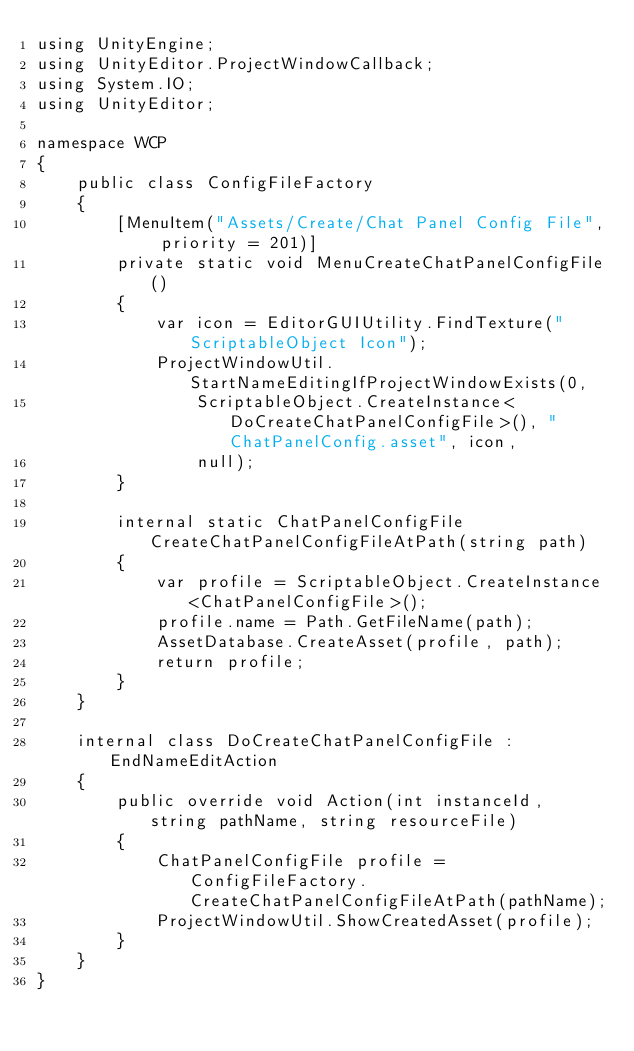<code> <loc_0><loc_0><loc_500><loc_500><_C#_>using UnityEngine;
using UnityEditor.ProjectWindowCallback;
using System.IO;
using UnityEditor;

namespace WCP
{
    public class ConfigFileFactory
    {
        [MenuItem("Assets/Create/Chat Panel Config File", priority = 201)]
        private static void MenuCreateChatPanelConfigFile()
        {
            var icon = EditorGUIUtility.FindTexture("ScriptableObject Icon");
            ProjectWindowUtil.StartNameEditingIfProjectWindowExists(0,
                ScriptableObject.CreateInstance<DoCreateChatPanelConfigFile>(), "ChatPanelConfig.asset", icon,
                null);
        }

        internal static ChatPanelConfigFile CreateChatPanelConfigFileAtPath(string path)
        {
            var profile = ScriptableObject.CreateInstance<ChatPanelConfigFile>();
            profile.name = Path.GetFileName(path);
            AssetDatabase.CreateAsset(profile, path);
            return profile;
        }
    }

    internal class DoCreateChatPanelConfigFile : EndNameEditAction
    {
        public override void Action(int instanceId, string pathName, string resourceFile)
        {
            ChatPanelConfigFile profile = ConfigFileFactory.CreateChatPanelConfigFileAtPath(pathName);
            ProjectWindowUtil.ShowCreatedAsset(profile);
        }
    }
}</code> 